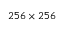Convert formula to latex. <formula><loc_0><loc_0><loc_500><loc_500>2 5 6 \times 2 5 6</formula> 